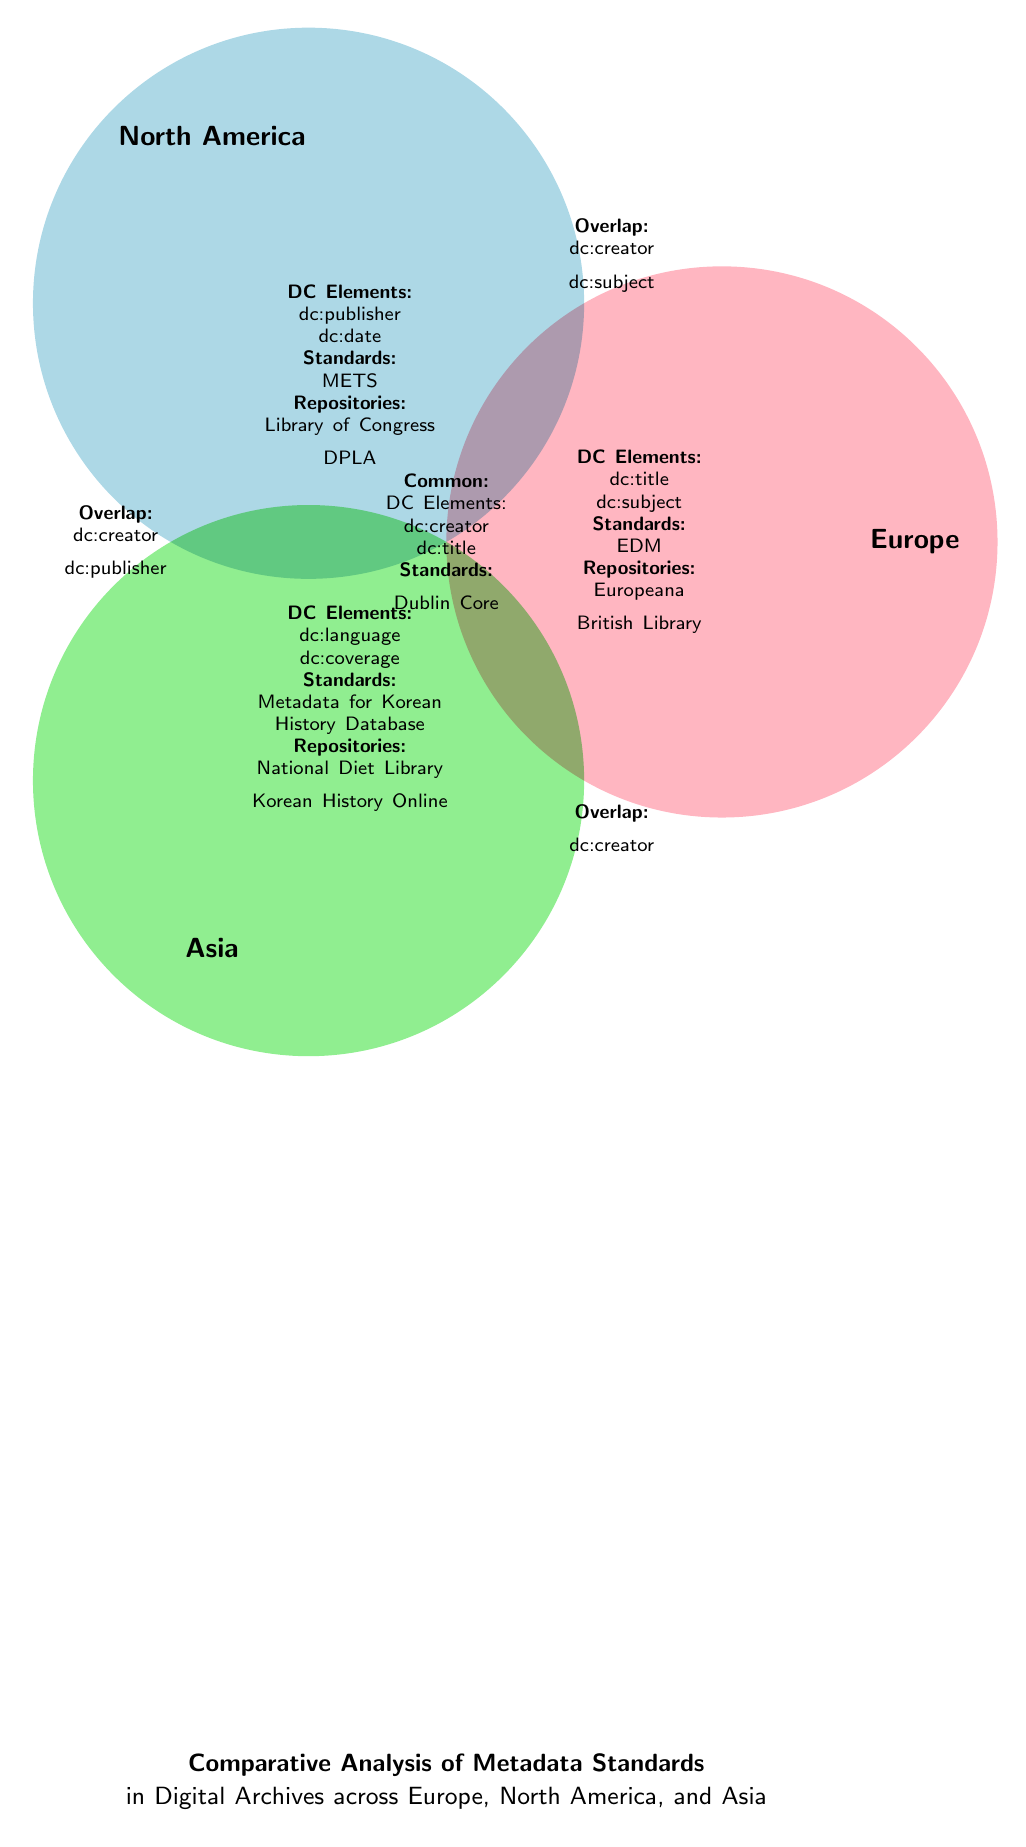What are the DC elements used in Europe? The diagram lists the DC elements for Europe in the corresponding section, which includes "dc:title" and "dc:subject."
Answer: dc:title, dc:subject Which metadata standard is associated with North America? In the North America section of the diagram, the listed standard is "METS."
Answer: METS How many common DC elements can be identified in the diagram? The common section indicates "dc:creator" and "dc:title," showing there are 2 common elements shared among the regions.
Answer: 2 Which DC element is found in all three regions? The common section specifically lists "dc:creator," indicating its presence in Europe, North America, and Asia.
Answer: dc:creator What repository is mentioned for Asia? The Asia section identifies "National Diet Library" as one of the repositories listed for that region.
Answer: National Diet Library How many overlaps are indicated in the diagram? The diagram reveals there are three overlaps mentioned: one for Europe and North America, one for Asia and North America, and one for Europe and Asia, resulting in a total of four overlaps.
Answer: 4 Which two regions share the DC element "dc:creator"? Referring to the overlaps, both Europe and North America, as well as Asia, share the "dc:creator" element.
Answer: Europe and North America; Asia What does the central area of the Venn diagram represent? The center of the Venn diagram lists "DC Elements," which includes elements that are common across all three regions, specifically showing the commonality in the use of "dc:creator" and "dc:title."
Answer: Common DC Elements What unique standard does Asia use for metadata? The Asia section distinctly mentions the "Metadata for Korean History Database" as a unique standard employed in that region.
Answer: Metadata for Korean History Database 